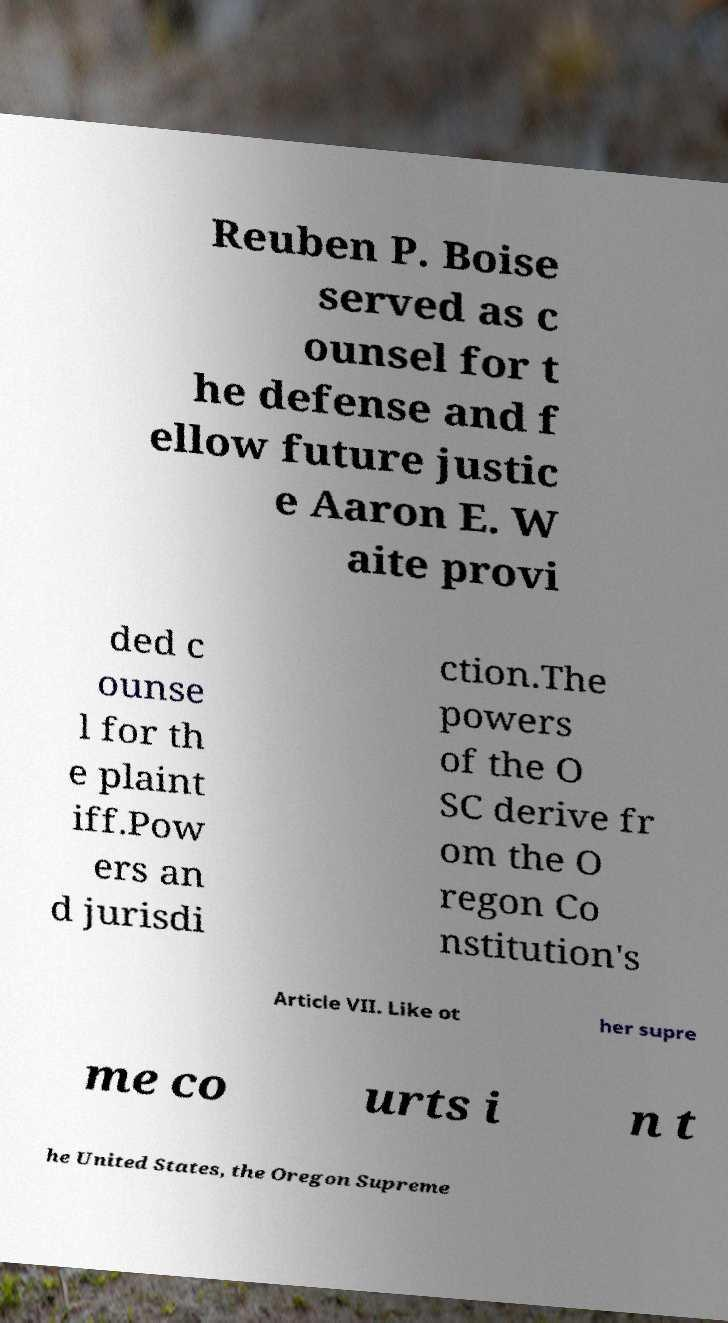Could you extract and type out the text from this image? Reuben P. Boise served as c ounsel for t he defense and f ellow future justic e Aaron E. W aite provi ded c ounse l for th e plaint iff.Pow ers an d jurisdi ction.The powers of the O SC derive fr om the O regon Co nstitution's Article VII. Like ot her supre me co urts i n t he United States, the Oregon Supreme 